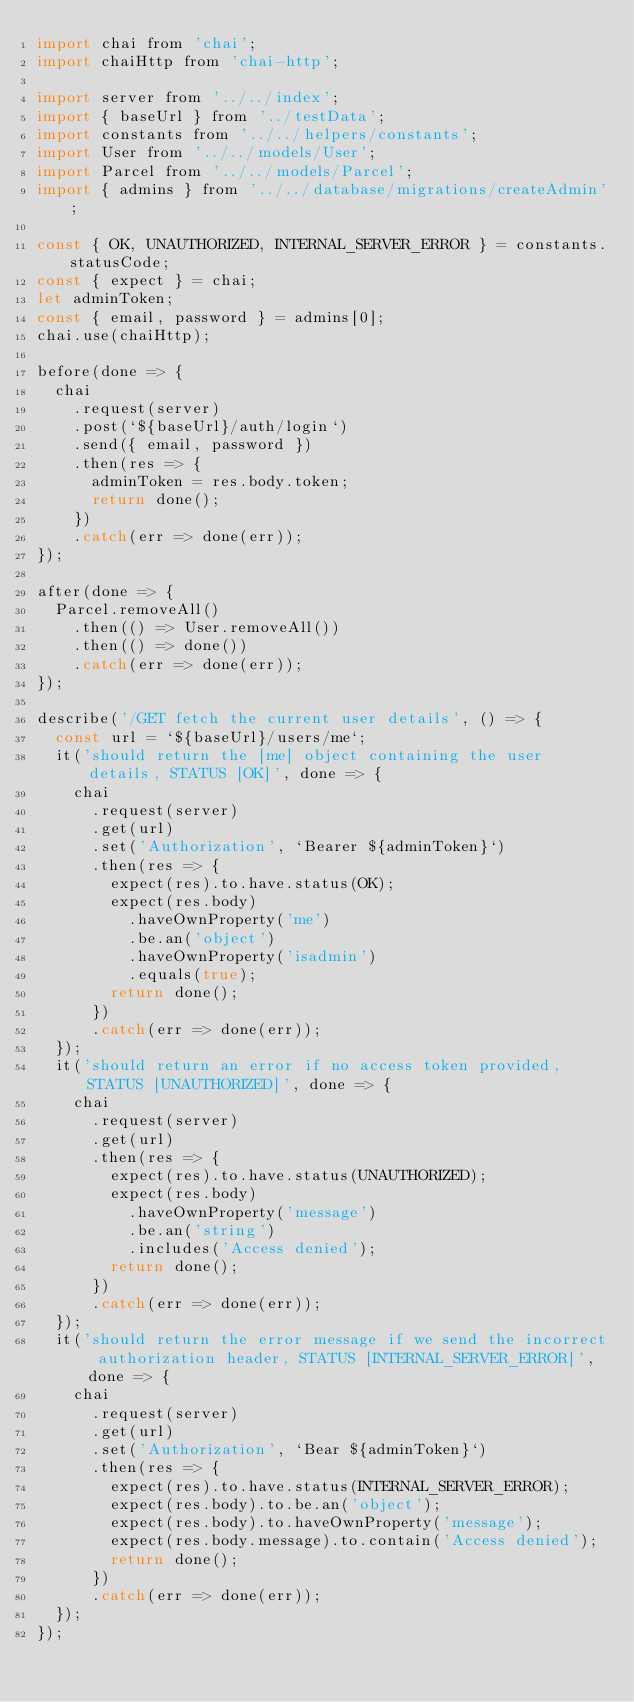Convert code to text. <code><loc_0><loc_0><loc_500><loc_500><_JavaScript_>import chai from 'chai';
import chaiHttp from 'chai-http';

import server from '../../index';
import { baseUrl } from '../testData';
import constants from '../../helpers/constants';
import User from '../../models/User';
import Parcel from '../../models/Parcel';
import { admins } from '../../database/migrations/createAdmin';

const { OK, UNAUTHORIZED, INTERNAL_SERVER_ERROR } = constants.statusCode;
const { expect } = chai;
let adminToken;
const { email, password } = admins[0];
chai.use(chaiHttp);

before(done => {
  chai
    .request(server)
    .post(`${baseUrl}/auth/login`)
    .send({ email, password })
    .then(res => {
      adminToken = res.body.token;
      return done();
    })
    .catch(err => done(err));
});

after(done => {
  Parcel.removeAll()
    .then(() => User.removeAll())
    .then(() => done())
    .catch(err => done(err));
});

describe('/GET fetch the current user details', () => {
  const url = `${baseUrl}/users/me`;
  it('should return the [me] object containing the user details, STATUS [OK]', done => {
    chai
      .request(server)
      .get(url)
      .set('Authorization', `Bearer ${adminToken}`)
      .then(res => {
        expect(res).to.have.status(OK);
        expect(res.body)
          .haveOwnProperty('me')
          .be.an('object')
          .haveOwnProperty('isadmin')
          .equals(true);
        return done();
      })
      .catch(err => done(err));
  });
  it('should return an error if no access token provided, STATUS [UNAUTHORIZED]', done => {
    chai
      .request(server)
      .get(url)
      .then(res => {
        expect(res).to.have.status(UNAUTHORIZED);
        expect(res.body)
          .haveOwnProperty('message')
          .be.an('string')
          .includes('Access denied');
        return done();
      })
      .catch(err => done(err));
  });
  it('should return the error message if we send the incorrect authorization header, STATUS [INTERNAL_SERVER_ERROR]', done => {
    chai
      .request(server)
      .get(url)
      .set('Authorization', `Bear ${adminToken}`)
      .then(res => {
        expect(res).to.have.status(INTERNAL_SERVER_ERROR);
        expect(res.body).to.be.an('object');
        expect(res.body).to.haveOwnProperty('message');
        expect(res.body.message).to.contain('Access denied');
        return done();
      })
      .catch(err => done(err));
  });
});
</code> 